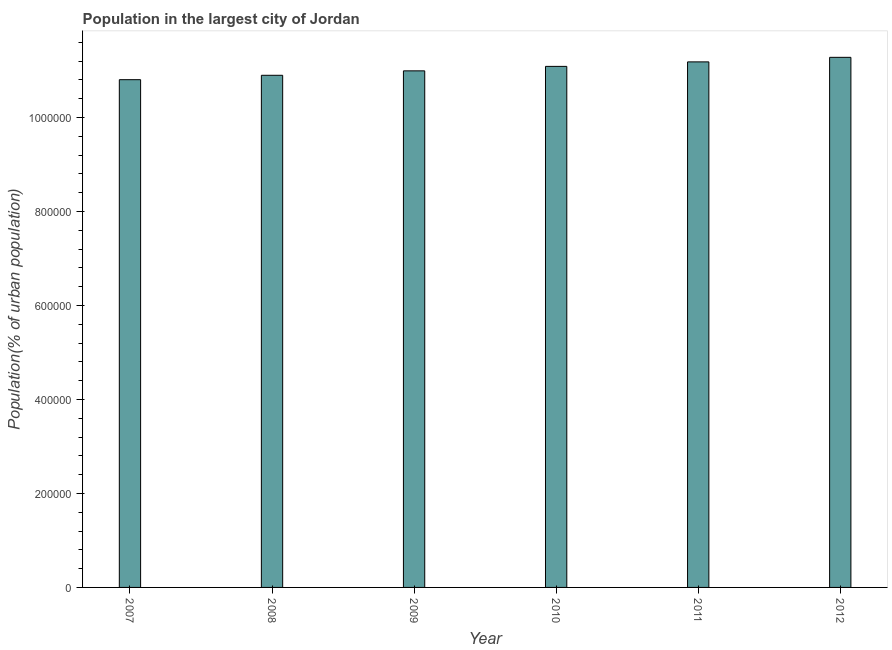What is the title of the graph?
Offer a very short reply. Population in the largest city of Jordan. What is the label or title of the X-axis?
Offer a terse response. Year. What is the label or title of the Y-axis?
Your answer should be very brief. Population(% of urban population). What is the population in largest city in 2009?
Make the answer very short. 1.10e+06. Across all years, what is the maximum population in largest city?
Offer a very short reply. 1.13e+06. Across all years, what is the minimum population in largest city?
Give a very brief answer. 1.08e+06. In which year was the population in largest city maximum?
Your answer should be very brief. 2012. In which year was the population in largest city minimum?
Ensure brevity in your answer.  2007. What is the sum of the population in largest city?
Provide a succinct answer. 6.63e+06. What is the difference between the population in largest city in 2007 and 2011?
Offer a terse response. -3.79e+04. What is the average population in largest city per year?
Your answer should be compact. 1.10e+06. What is the median population in largest city?
Ensure brevity in your answer.  1.10e+06. In how many years, is the population in largest city greater than 600000 %?
Provide a succinct answer. 6. Do a majority of the years between 2008 and 2012 (inclusive) have population in largest city greater than 40000 %?
Offer a terse response. Yes. What is the ratio of the population in largest city in 2009 to that in 2012?
Offer a very short reply. 0.97. Is the population in largest city in 2011 less than that in 2012?
Your response must be concise. Yes. What is the difference between the highest and the second highest population in largest city?
Provide a succinct answer. 9679. Is the sum of the population in largest city in 2010 and 2011 greater than the maximum population in largest city across all years?
Ensure brevity in your answer.  Yes. What is the difference between the highest and the lowest population in largest city?
Offer a terse response. 4.76e+04. How many bars are there?
Keep it short and to the point. 6. What is the difference between two consecutive major ticks on the Y-axis?
Your answer should be very brief. 2.00e+05. What is the Population(% of urban population) in 2007?
Provide a short and direct response. 1.08e+06. What is the Population(% of urban population) in 2008?
Provide a succinct answer. 1.09e+06. What is the Population(% of urban population) of 2009?
Keep it short and to the point. 1.10e+06. What is the Population(% of urban population) of 2010?
Offer a terse response. 1.11e+06. What is the Population(% of urban population) of 2011?
Your response must be concise. 1.12e+06. What is the Population(% of urban population) of 2012?
Ensure brevity in your answer.  1.13e+06. What is the difference between the Population(% of urban population) in 2007 and 2008?
Offer a very short reply. -9351. What is the difference between the Population(% of urban population) in 2007 and 2009?
Make the answer very short. -1.88e+04. What is the difference between the Population(% of urban population) in 2007 and 2010?
Your answer should be very brief. -2.83e+04. What is the difference between the Population(% of urban population) in 2007 and 2011?
Offer a very short reply. -3.79e+04. What is the difference between the Population(% of urban population) in 2007 and 2012?
Provide a succinct answer. -4.76e+04. What is the difference between the Population(% of urban population) in 2008 and 2009?
Provide a short and direct response. -9431. What is the difference between the Population(% of urban population) in 2008 and 2010?
Give a very brief answer. -1.89e+04. What is the difference between the Population(% of urban population) in 2008 and 2011?
Offer a very short reply. -2.85e+04. What is the difference between the Population(% of urban population) in 2008 and 2012?
Offer a very short reply. -3.82e+04. What is the difference between the Population(% of urban population) in 2009 and 2010?
Provide a short and direct response. -9514. What is the difference between the Population(% of urban population) in 2009 and 2011?
Ensure brevity in your answer.  -1.91e+04. What is the difference between the Population(% of urban population) in 2009 and 2012?
Offer a terse response. -2.88e+04. What is the difference between the Population(% of urban population) in 2010 and 2011?
Provide a short and direct response. -9595. What is the difference between the Population(% of urban population) in 2010 and 2012?
Make the answer very short. -1.93e+04. What is the difference between the Population(% of urban population) in 2011 and 2012?
Ensure brevity in your answer.  -9679. What is the ratio of the Population(% of urban population) in 2007 to that in 2008?
Offer a very short reply. 0.99. What is the ratio of the Population(% of urban population) in 2007 to that in 2010?
Offer a terse response. 0.97. What is the ratio of the Population(% of urban population) in 2007 to that in 2012?
Your response must be concise. 0.96. What is the ratio of the Population(% of urban population) in 2008 to that in 2009?
Give a very brief answer. 0.99. What is the ratio of the Population(% of urban population) in 2008 to that in 2010?
Offer a terse response. 0.98. What is the ratio of the Population(% of urban population) in 2008 to that in 2012?
Keep it short and to the point. 0.97. What is the ratio of the Population(% of urban population) in 2009 to that in 2012?
Offer a terse response. 0.97. 